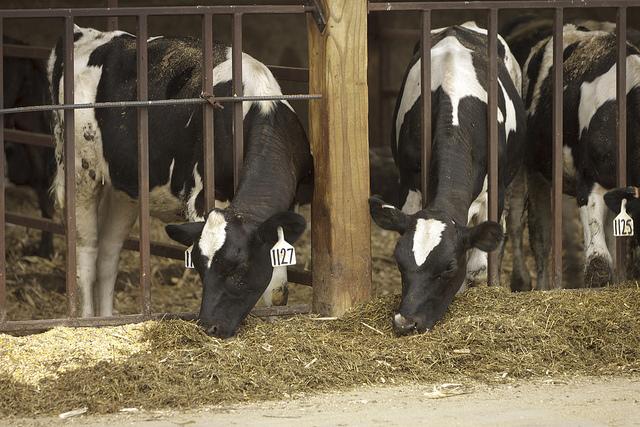What are the cows doing?
Answer briefly. Eating. What color are the cows?
Quick response, please. Black and white. Are these cows for milk production?
Concise answer only. Yes. 